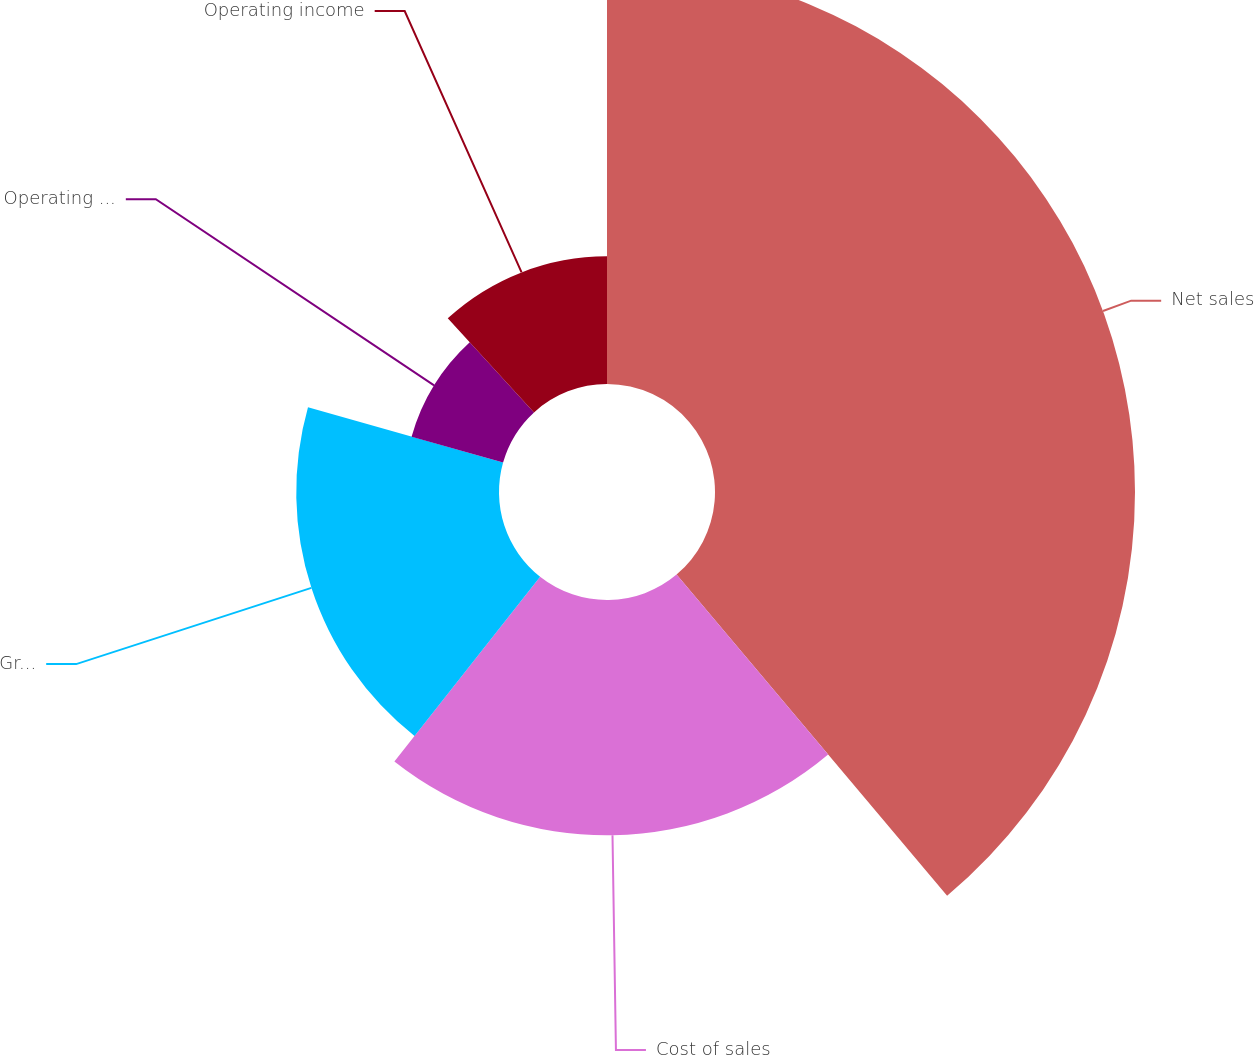Convert chart. <chart><loc_0><loc_0><loc_500><loc_500><pie_chart><fcel>Net sales<fcel>Cost of sales<fcel>Gross profit<fcel>Operating expenses<fcel>Operating income<nl><fcel>38.86%<fcel>21.77%<fcel>18.76%<fcel>8.8%<fcel>11.81%<nl></chart> 